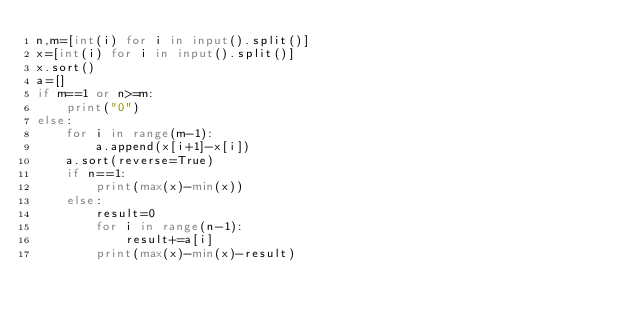Convert code to text. <code><loc_0><loc_0><loc_500><loc_500><_Python_>n,m=[int(i) for i in input().split()]
x=[int(i) for i in input().split()]
x.sort()
a=[]
if m==1 or n>=m:
    print("0")
else:
    for i in range(m-1):
        a.append(x[i+1]-x[i])
    a.sort(reverse=True)
    if n==1:
        print(max(x)-min(x))
    else:
        result=0
        for i in range(n-1):
            result+=a[i]
        print(max(x)-min(x)-result)</code> 